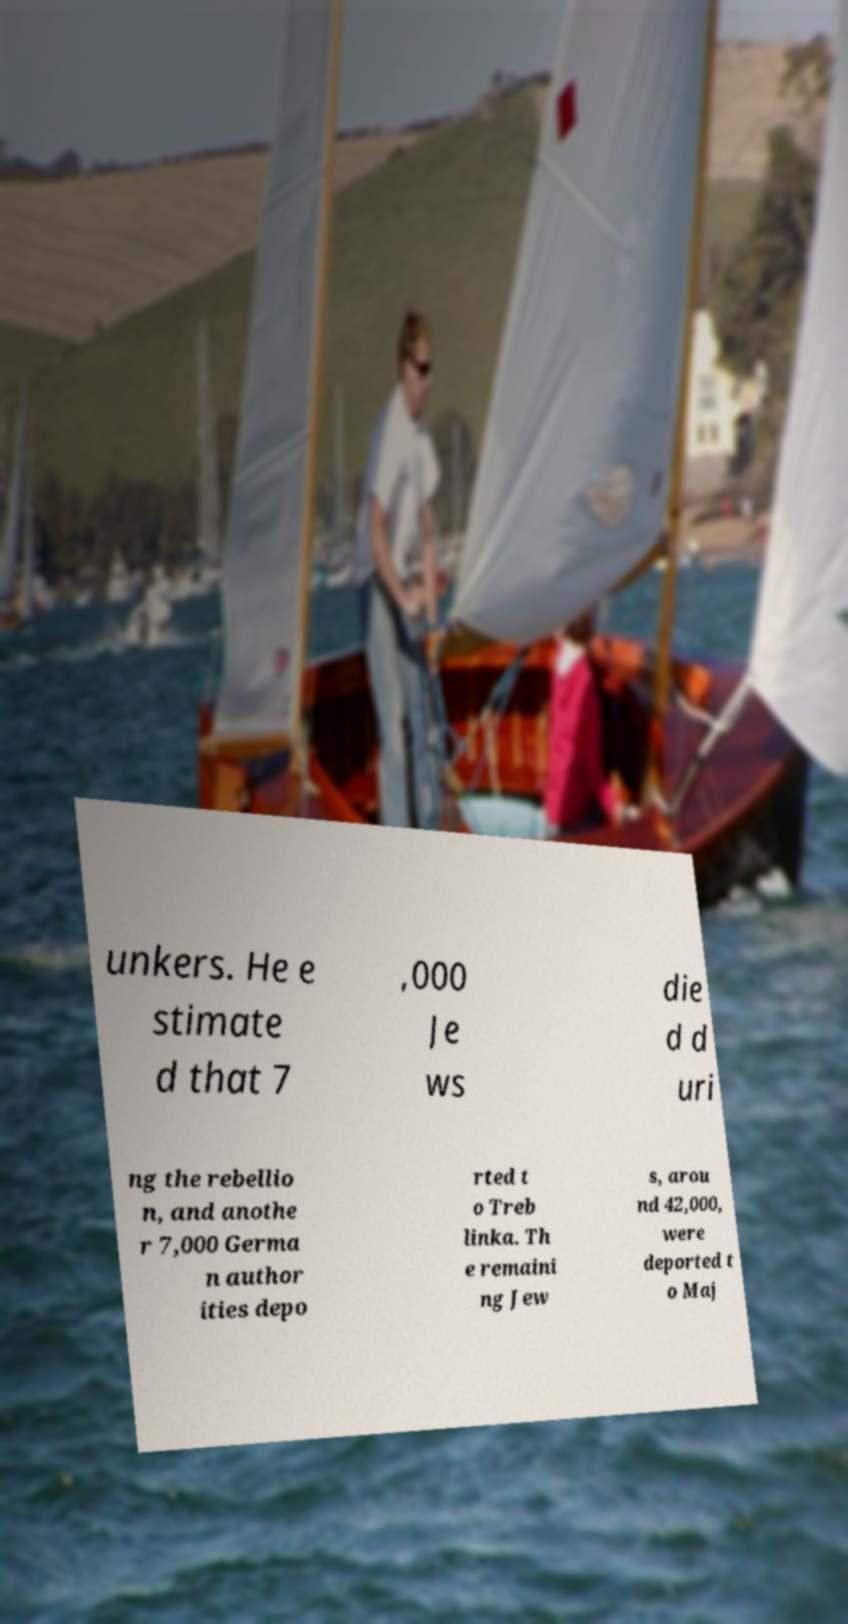Please identify and transcribe the text found in this image. unkers. He e stimate d that 7 ,000 Je ws die d d uri ng the rebellio n, and anothe r 7,000 Germa n author ities depo rted t o Treb linka. Th e remaini ng Jew s, arou nd 42,000, were deported t o Maj 